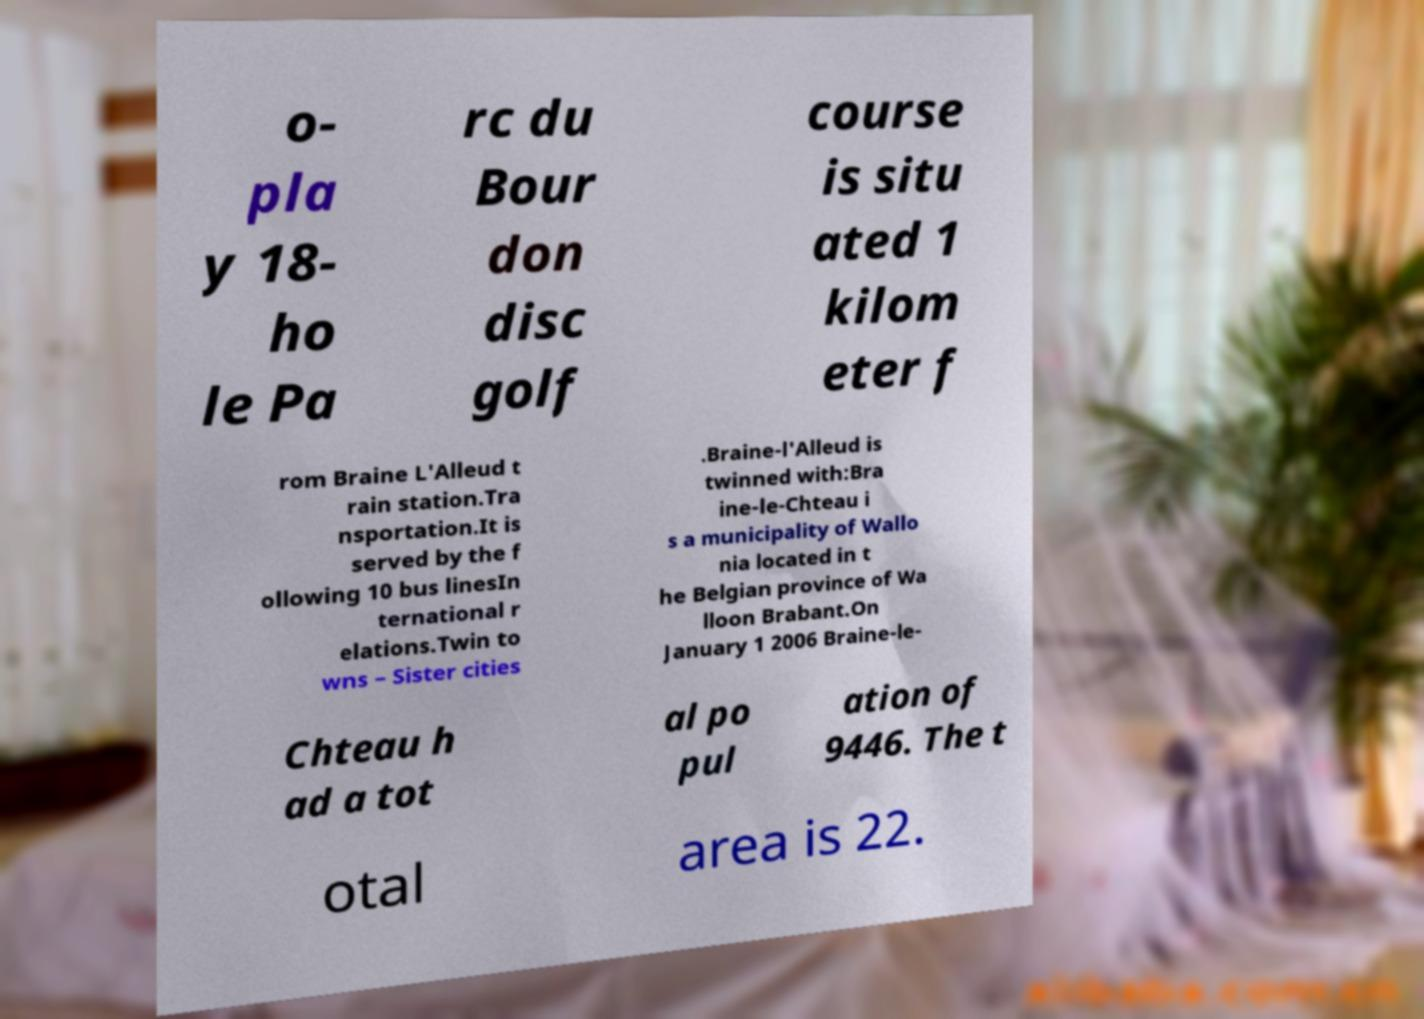Could you extract and type out the text from this image? o- pla y 18- ho le Pa rc du Bour don disc golf course is situ ated 1 kilom eter f rom Braine L'Alleud t rain station.Tra nsportation.It is served by the f ollowing 10 bus linesIn ternational r elations.Twin to wns – Sister cities .Braine-l'Alleud is twinned with:Bra ine-le-Chteau i s a municipality of Wallo nia located in t he Belgian province of Wa lloon Brabant.On January 1 2006 Braine-le- Chteau h ad a tot al po pul ation of 9446. The t otal area is 22. 